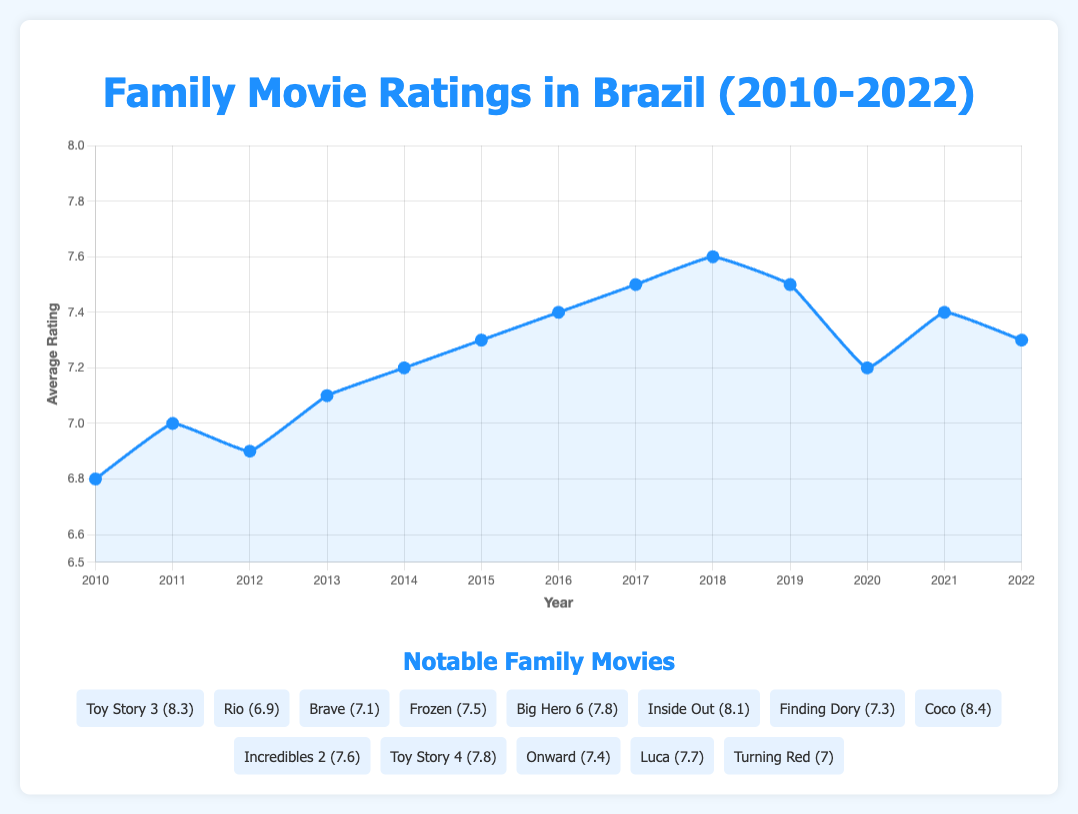What was the average family movie rating in Brazil in 2015? The plot shows the average rating for each year. Look for the year 2015 on the x-axis and check the corresponding y-axis value, which should be around 7.3.
Answer: 7.3 How does the average rating in 2015 compare to the rating in 2014? To compare the ratings, find the values for both years on the y-axis. In 2014, the rating is 7.2, and in 2015, it is 7.3. Thus, the rating in 2015 is slightly higher than in 2014 by 0.1.
Answer: 0.1 higher Which year had the highest average family movie rating? Look at the peak of the line plot to identify the highest point on the y-axis, which corresponds to the year 2018, where the average rating is 7.6.
Answer: 2018 In what years did the average rating decrease compared to the previous year? Identify the points where the line goes downward. These instances can be seen from 2011 to 2012 and 2019 to 2020.
Answer: 2012, 2020 How much did the average rating change from 2019 to 2020? Look at the ratings for 2019 and 2020, which are 7.5 and 7.2 respectively. Subtract 7.2 from 7.5 to get the difference of 0.3.
Answer: 0.3 Which notable family movie had the highest rating, and what was its rating? In the notable movies list, find the movie with the highest score. "Coco" has the highest rating with an 8.4.
Answer: Coco, 8.4 Was the average rating trend from 2010 to 2022 mostly increasing, decreasing, or mixed? Observe the general direction of the line plot. Note that from 2010 to 2018, the trend is mostly upward, followed by a slight decrease and fluctuation. Overall, it is increasing.
Answer: Increasing How did the average rating in 2020 compare with the rating in 2021? Observe the values for both years on the y-axis. In 2020, the rating is 7.2, and in 2021, it is 7.4. Thus, the rating in 2021 is higher by 0.2.
Answer: 0.2 higher What is the average rating of all notable family movies listed? Sum the ratings of all notable movies (8.3 + 6.9 + 7.1 + 7.5 + 7.8 + 8.1 + 7.3 + 8.4 + 7.6 + 7.8 + 7.4 + 7.7 + 7.0) and then divide by the number of movies (13). The sum is 95.9, so the average is 95.9 / 13 = 7.38.
Answer: 7.38 